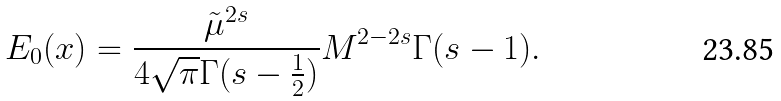<formula> <loc_0><loc_0><loc_500><loc_500>E _ { 0 } ( x ) = \frac { \tilde { \mu } ^ { 2 s } } { 4 \sqrt { \pi } \Gamma ( s - \frac { 1 } { 2 } ) } M ^ { 2 - 2 s } \Gamma ( s - 1 ) .</formula> 